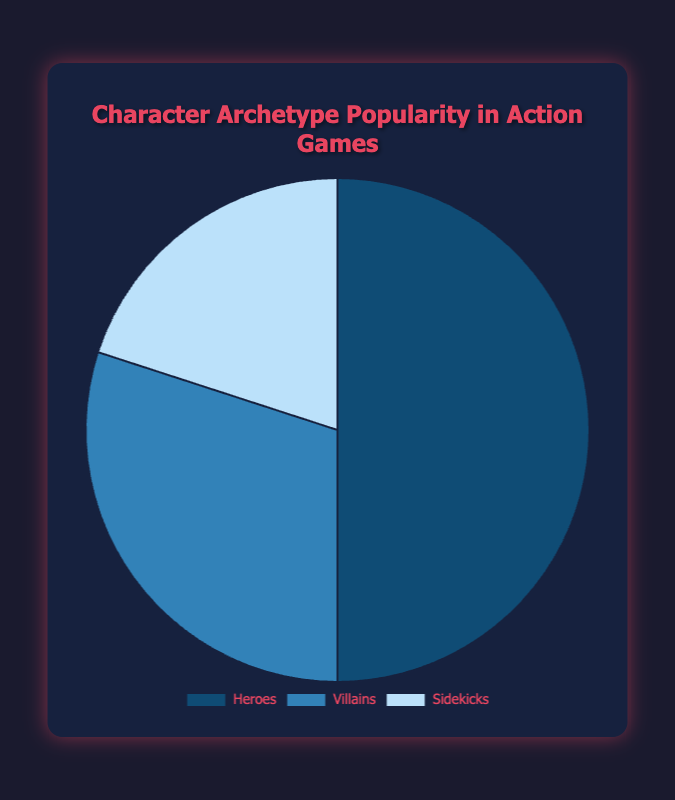Which character archetype is most popular in action games? The pie chart shows that Heroes occupy the largest portion of the chart compared to Villains and Sidekicks. Hence, Heroes are the most popular character archetype.
Answer: Heroes Which character archetype is least popular in action games? The pie chart shows that Sidekicks occupy the smallest portion of the chart compared to Heroes and Villains. Hence, Sidekicks are the least popular character archetype.
Answer: Sidekicks How many more percentage points do Heroes have compared to Villains? By examining the data, Heroes have a popularity of 50%, while Villains have 30%. The difference is calculated as 50% - 30% = 20%.
Answer: 20% How much less popular are Sidekicks than Heroes and Villains combined? Heroes and Villains combined have: 50% (Heroes) + 30% (Villains) = 80%. Given Sidekicks have 20%, the difference is 80% - 20% = 60%.
Answer: 60% Are Sidekicks more or less popular than the sum of the popularity of Villains and one-fourth of Heroes? Villains have 30% and one-fourth of Heroes is 50% / 4 = 12.5%. The sum is 30% + 12.5% = 42.5%. Sidekicks have 20%, which is less.
Answer: Less What is the ratio of Heroes to Sidekicks in terms of popularity? The popularity of Heroes is 50%, and Sidekicks is 20%. The ratio is calculated as 50% / 20% = 2.5:1.
Answer: 2.5:1 How much more popular are Heroes compared to the average popularity of the three archetypes? Average popularity is calculated as (50% + 30% + 20%) / 3 = 33.33%. Difference is 50% (Heroes) - 33.33% = 16.67%.
Answer: 16.67% What percentage of the total does the sum of Heroes and Sidekicks represent? Summing Heroes and Sidekicks gives 50% + 20% = 70%.
Answer: 70% Which character archetype has the second largest portion in the pie chart? Upon examining the size of portions, Villains occupy the second largest portion after Heroes.
Answer: Villains 